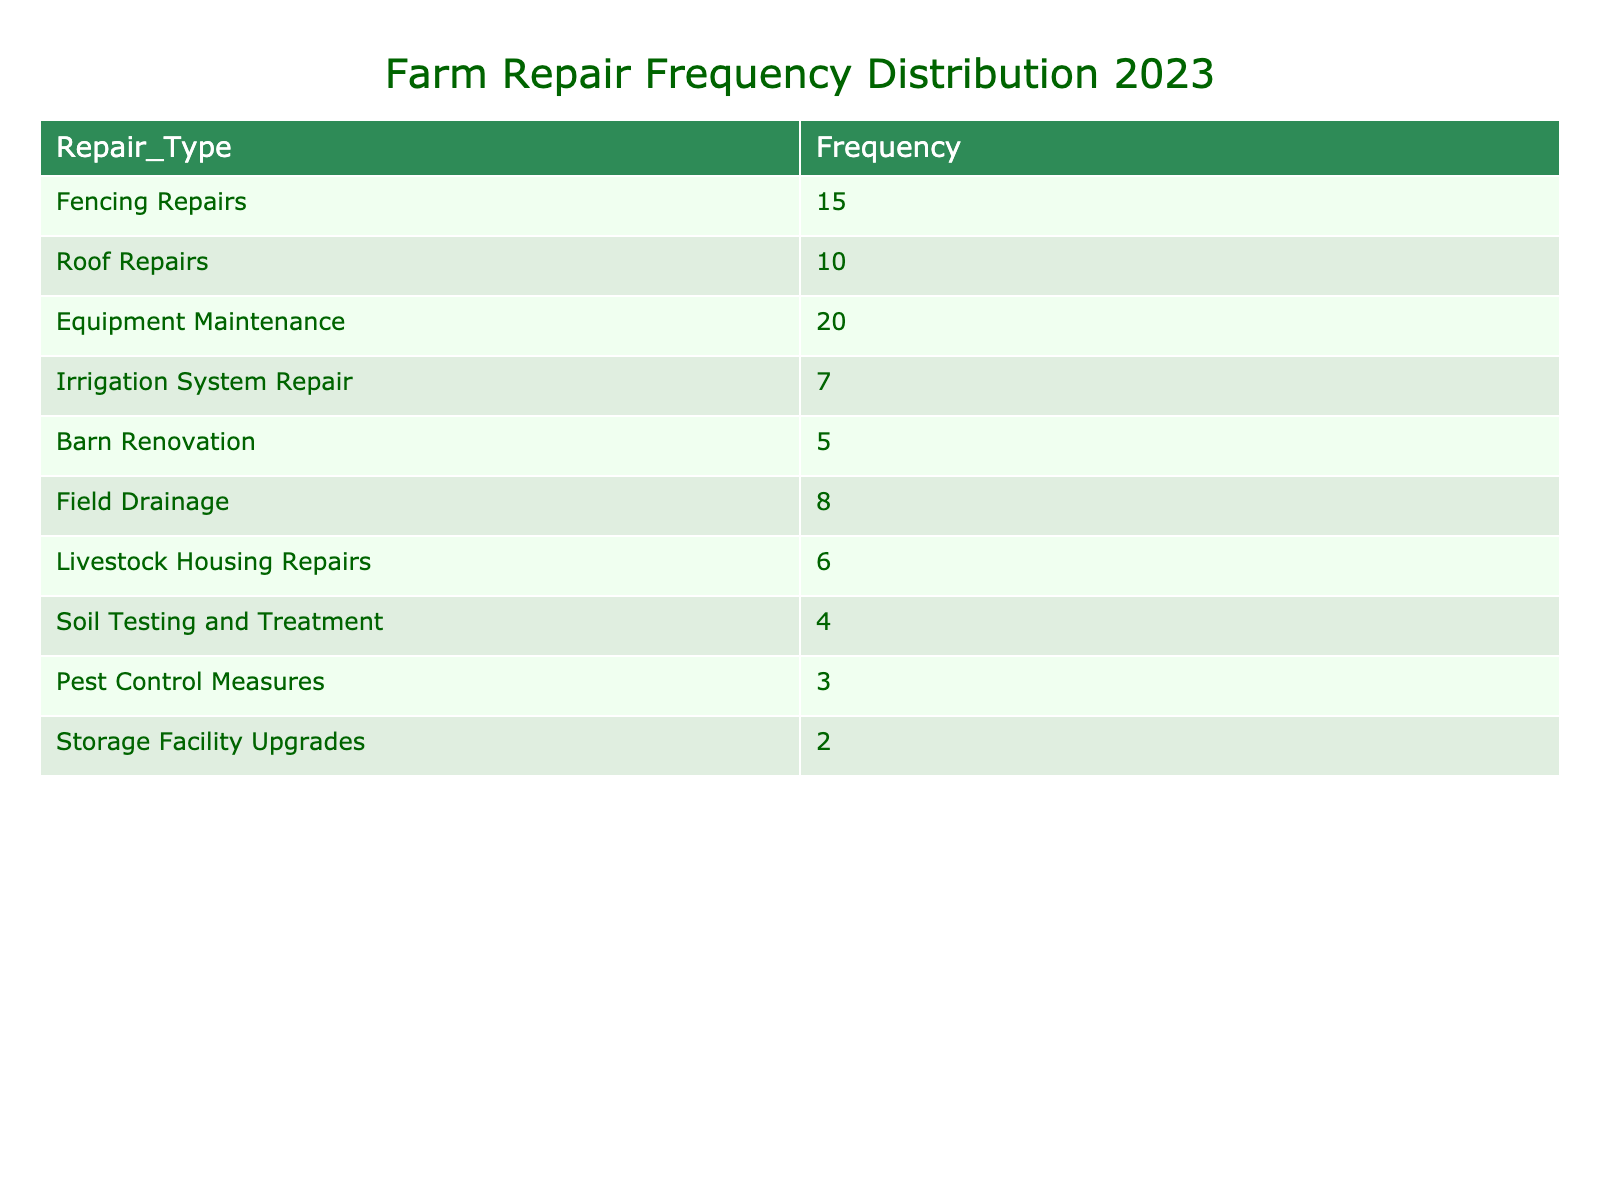What type of repair has the highest frequency in 2023? From the table, "Equipment Maintenance" has a frequency of 20, which is the highest among all repair types listed.
Answer: Equipment Maintenance How many total repairs are needed across all types in 2023? To find the total, add all the frequencies together: 15 (Fencing Repairs) + 10 (Roof Repairs) + 20 (Equipment Maintenance) + 7 (Irrigation System Repair) + 5 (Barn Renovation) + 8 (Field Drainage) + 6 (Livestock Housing Repairs) + 4 (Soil Testing and Treatment) + 3 (Pest Control Measures) + 2 (Storage Facility Upgrades) = 80.
Answer: 80 Is the frequency of "Pest Control Measures" greater than or equal to "Soil Testing and Treatment"? The frequency of "Pest Control Measures" is 3, while "Soil Testing and Treatment" has a frequency of 4. Since 3 is less than 4, the statement is false.
Answer: False What is the average frequency of repairs listed in the table? There are 10 repair types. The total frequency is 80 (calculated previously). To find the average, divide the total frequency by the number of types: 80 / 10 = 8.
Answer: 8 Which repair type has the least frequency in 2023? The table shows "Storage Facility Upgrades" with a frequency of 2, which is the lowest when compared to all other types.
Answer: Storage Facility Upgrades How many more "Fencing Repairs" are needed compared to "Barn Renovation"? "Fencing Repairs" has a frequency of 15, and "Barn Renovation" has a frequency of 5. Subtract the two: 15 - 5 = 10.
Answer: 10 Is the frequency of "Roof Repairs" more than the frequency of "Livestock Housing Repairs"? "Roof Repairs" has a frequency of 10, while "Livestock Housing Repairs" has a frequency of 6. Since 10 is greater than 6, the statement is true.
Answer: True What are the combined frequencies of "Irrigation System Repair" and "Field Drainage"? The frequency of "Irrigation System Repair" is 7, and "Field Drainage" is 8. Adding these together gives 7 + 8 = 15.
Answer: 15 